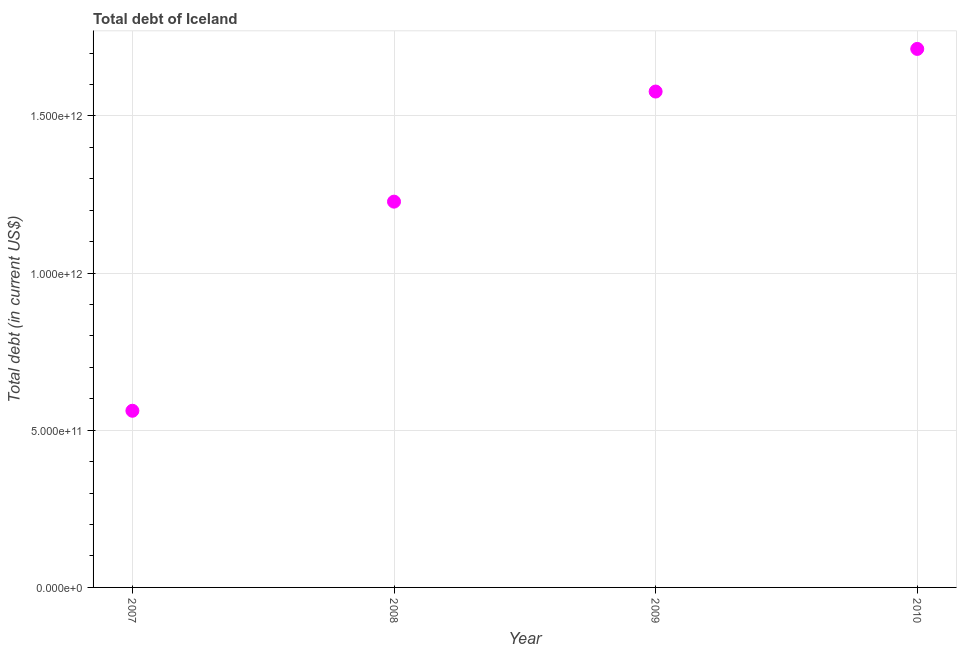What is the total debt in 2010?
Your answer should be very brief. 1.71e+12. Across all years, what is the maximum total debt?
Offer a terse response. 1.71e+12. Across all years, what is the minimum total debt?
Make the answer very short. 5.62e+11. In which year was the total debt maximum?
Give a very brief answer. 2010. What is the sum of the total debt?
Provide a short and direct response. 5.08e+12. What is the difference between the total debt in 2008 and 2009?
Make the answer very short. -3.50e+11. What is the average total debt per year?
Your response must be concise. 1.27e+12. What is the median total debt?
Make the answer very short. 1.40e+12. In how many years, is the total debt greater than 1300000000000 US$?
Provide a short and direct response. 2. What is the ratio of the total debt in 2009 to that in 2010?
Provide a succinct answer. 0.92. What is the difference between the highest and the second highest total debt?
Offer a terse response. 1.36e+11. Is the sum of the total debt in 2007 and 2009 greater than the maximum total debt across all years?
Your answer should be very brief. Yes. What is the difference between the highest and the lowest total debt?
Your answer should be very brief. 1.15e+12. What is the difference between two consecutive major ticks on the Y-axis?
Keep it short and to the point. 5.00e+11. Does the graph contain grids?
Your answer should be compact. Yes. What is the title of the graph?
Offer a very short reply. Total debt of Iceland. What is the label or title of the X-axis?
Your answer should be compact. Year. What is the label or title of the Y-axis?
Your answer should be very brief. Total debt (in current US$). What is the Total debt (in current US$) in 2007?
Give a very brief answer. 5.62e+11. What is the Total debt (in current US$) in 2008?
Provide a short and direct response. 1.23e+12. What is the Total debt (in current US$) in 2009?
Your answer should be very brief. 1.58e+12. What is the Total debt (in current US$) in 2010?
Offer a very short reply. 1.71e+12. What is the difference between the Total debt (in current US$) in 2007 and 2008?
Your answer should be compact. -6.65e+11. What is the difference between the Total debt (in current US$) in 2007 and 2009?
Your answer should be very brief. -1.02e+12. What is the difference between the Total debt (in current US$) in 2007 and 2010?
Your response must be concise. -1.15e+12. What is the difference between the Total debt (in current US$) in 2008 and 2009?
Keep it short and to the point. -3.50e+11. What is the difference between the Total debt (in current US$) in 2008 and 2010?
Your answer should be compact. -4.86e+11. What is the difference between the Total debt (in current US$) in 2009 and 2010?
Your answer should be compact. -1.36e+11. What is the ratio of the Total debt (in current US$) in 2007 to that in 2008?
Your answer should be compact. 0.46. What is the ratio of the Total debt (in current US$) in 2007 to that in 2009?
Offer a terse response. 0.36. What is the ratio of the Total debt (in current US$) in 2007 to that in 2010?
Offer a terse response. 0.33. What is the ratio of the Total debt (in current US$) in 2008 to that in 2009?
Give a very brief answer. 0.78. What is the ratio of the Total debt (in current US$) in 2008 to that in 2010?
Your response must be concise. 0.72. What is the ratio of the Total debt (in current US$) in 2009 to that in 2010?
Give a very brief answer. 0.92. 